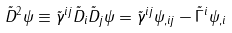Convert formula to latex. <formula><loc_0><loc_0><loc_500><loc_500>\tilde { D } ^ { 2 } \psi \equiv \tilde { \gamma } ^ { i j } \tilde { D } _ { i } \tilde { D } _ { j } \psi = \tilde { \gamma } ^ { i j } \psi _ { , i j } - \tilde { \Gamma } ^ { i } \psi _ { , i }</formula> 